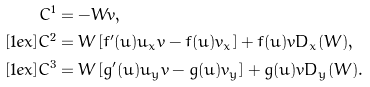<formula> <loc_0><loc_0><loc_500><loc_500>C ^ { 1 } & = - W v , \\ [ 1 e x ] C ^ { 2 } & = W \left [ f ^ { \prime } ( u ) u _ { x } v - f ( u ) v _ { x } \right ] + f ( u ) v D _ { x } ( W ) , \\ [ 1 e x ] C ^ { 3 } & = W \left [ g ^ { \prime } ( u ) u _ { y } v - g ( u ) v _ { y } \right ] + g ( u ) v D _ { y } ( W ) .</formula> 